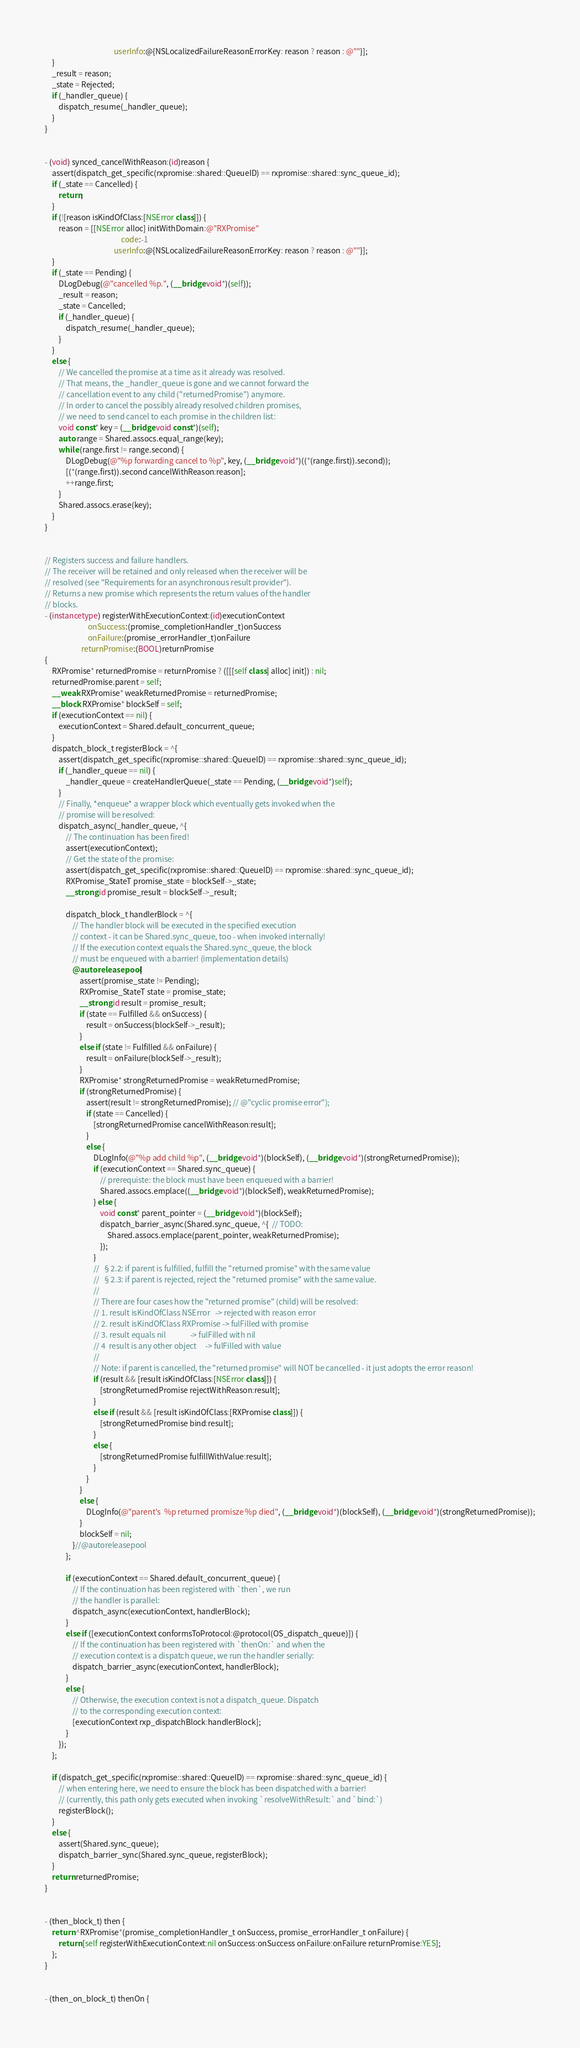<code> <loc_0><loc_0><loc_500><loc_500><_ObjectiveC_>                                        userInfo:@{NSLocalizedFailureReasonErrorKey: reason ? reason : @""}];
    }
    _result = reason;
    _state = Rejected;
    if (_handler_queue) {
        dispatch_resume(_handler_queue);
    }
}


- (void) synced_cancelWithReason:(id)reason {
    assert(dispatch_get_specific(rxpromise::shared::QueueID) == rxpromise::shared::sync_queue_id);
    if (_state == Cancelled) {
        return;
    }
    if (![reason isKindOfClass:[NSError class]]) {
        reason = [[NSError alloc] initWithDomain:@"RXPromise"
                                            code:-1
                                        userInfo:@{NSLocalizedFailureReasonErrorKey: reason ? reason : @""}];
    }
    if (_state == Pending) {
        DLogDebug(@"cancelled %p.", (__bridge void*)(self));
        _result = reason;
        _state = Cancelled;
        if (_handler_queue) {
            dispatch_resume(_handler_queue);
        }
    }
    else {
        // We cancelled the promise at a time as it already was resolved.
        // That means, the _handler_queue is gone and we cannot forward the
        // cancellation event to any child ("returnedPromise") anymore.
        // In order to cancel the possibly already resolved children promises,
        // we need to send cancel to each promise in the children list:
        void const* key = (__bridge void const*)(self);
        auto range = Shared.assocs.equal_range(key);
        while (range.first != range.second) {
            DLogDebug(@"%p forwarding cancel to %p", key, (__bridge void*)((*(range.first)).second));
            [(*(range.first)).second cancelWithReason:reason];
            ++range.first;
        }
        Shared.assocs.erase(key);
    }
}


// Registers success and failure handlers.
// The receiver will be retained and only released when the receiver will be
// resolved (see "Requirements for an asynchronous result provider").
// Returns a new promise which represents the return values of the handler
// blocks.
- (instancetype) registerWithExecutionContext:(id)executionContext
                         onSuccess:(promise_completionHandler_t)onSuccess
                         onFailure:(promise_errorHandler_t)onFailure
                     returnPromise:(BOOL)returnPromise
{
    RXPromise* returnedPromise = returnPromise ? ([[[self class] alloc] init]) : nil;
    returnedPromise.parent = self;
    __weak RXPromise* weakReturnedPromise = returnedPromise;
    __block RXPromise* blockSelf = self;
    if (executionContext == nil) {
        executionContext = Shared.default_concurrent_queue;
    }
    dispatch_block_t registerBlock = ^{
        assert(dispatch_get_specific(rxpromise::shared::QueueID) == rxpromise::shared::sync_queue_id);
        if (_handler_queue == nil) {
            _handler_queue = createHandlerQueue(_state == Pending, (__bridge void*)self);
        }
        // Finally, *enqueue* a wrapper block which eventually gets invoked when the
        // promise will be resolved:
        dispatch_async(_handler_queue, ^{
            // The continuation has been fired!
            assert(executionContext);
            // Get the state of the promise:
            assert(dispatch_get_specific(rxpromise::shared::QueueID) == rxpromise::shared::sync_queue_id);
            RXPromise_StateT promise_state = blockSelf->_state;
            __strong id promise_result = blockSelf->_result;
            
            dispatch_block_t handlerBlock = ^{
                // The handler block will be executed in the specified execution
                // context - it can be Shared.sync_queue, too - when invoked internally!
                // If the execution context equals the Shared.sync_queue, the block
                // must be enqueued with a barrier! (implementation details)
                @autoreleasepool {
                    assert(promise_state != Pending);
                    RXPromise_StateT state = promise_state;
                    __strong id result = promise_result;
                    if (state == Fulfilled && onSuccess) {
                        result = onSuccess(blockSelf->_result);
                    }
                    else if (state != Fulfilled && onFailure) {
                        result = onFailure(blockSelf->_result);
                    }
                    RXPromise* strongReturnedPromise = weakReturnedPromise;
                    if (strongReturnedPromise) {
                        assert(result != strongReturnedPromise); // @"cyclic promise error");
                        if (state == Cancelled) {
                            [strongReturnedPromise cancelWithReason:result];
                        }
                        else {
                            DLogInfo(@"%p add child %p", (__bridge void*)(blockSelf), (__bridge void*)(strongReturnedPromise));
                            if (executionContext == Shared.sync_queue) {
                                // prerequiste: the block must have been enqueued with a barrier!
                                Shared.assocs.emplace((__bridge void*)(blockSelf), weakReturnedPromise);
                            } else {
                                void const* parent_pointer = (__bridge void*)(blockSelf);
                                dispatch_barrier_async(Shared.sync_queue, ^{  // TODO:
                                    Shared.assocs.emplace(parent_pointer, weakReturnedPromise);
                                }); 
                            }
                            //  §2.2: if parent is fulfilled, fulfill the "returned promise" with the same value
                            //  §2.3: if parent is rejected, reject the "returned promise" with the same value.
                            //
                            // There are four cases how the "returned promise" (child) will be resolved:
                            // 1. result isKindOfClass NSError   -> rejected with reason error
                            // 2. result isKindOfClass RXPromise -> fulFilled with promise
                            // 3. result equals nil              -> fulFilled with nil
                            // 4  result is any other object     -> fulFilled with value
                            //
                            // Note: if parent is cancelled, the "returned promise" will NOT be cancelled - it just adopts the error reason!
                            if (result && [result isKindOfClass:[NSError class]]) {
                                [strongReturnedPromise rejectWithReason:result];
                            }
                            else if (result && [result isKindOfClass:[RXPromise class]]) {
                                [strongReturnedPromise bind:result];
                            }
                            else {
                                [strongReturnedPromise fulfillWithValue:result];
                            }
                        }
                    }
                    else {
                        DLogInfo(@"parent's  %p returned promisze %p died", (__bridge void*)(blockSelf), (__bridge void*)(strongReturnedPromise));
                    }
                    blockSelf = nil;
                }//@autoreleasepool
            };
            
            if (executionContext == Shared.default_concurrent_queue) {
                // If the continuation has been registered with `then`, we run
                // the handler is parallel:
                dispatch_async(executionContext, handlerBlock);
            }
            else if ([executionContext conformsToProtocol:@protocol(OS_dispatch_queue)]) {
                // If the continuation has been registered with `thenOn:` and when the
                // execution context is a dispatch queue, we run the handler serially:
                dispatch_barrier_async(executionContext, handlerBlock);
            }
            else {
                // Otherwise, the execution context is not a dispatch_queue. Dispatch
                // to the corresponding execution context:
                [executionContext rxp_dispatchBlock:handlerBlock];
            }
        });
    };
    
    if (dispatch_get_specific(rxpromise::shared::QueueID) == rxpromise::shared::sync_queue_id) {
        // when entering here, we need to ensure the block has been dispatched with a barrier!
        // (currently, this path only gets executed when invoking `resolveWithResult:` and `bind:`)
        registerBlock();
    }
    else {
        assert(Shared.sync_queue);
        dispatch_barrier_sync(Shared.sync_queue, registerBlock);
    }
    return returnedPromise;
}


- (then_block_t) then {
    return ^RXPromise*(promise_completionHandler_t onSuccess, promise_errorHandler_t onFailure) {
        return [self registerWithExecutionContext:nil onSuccess:onSuccess onFailure:onFailure returnPromise:YES];
    };
}


- (then_on_block_t) thenOn {</code> 